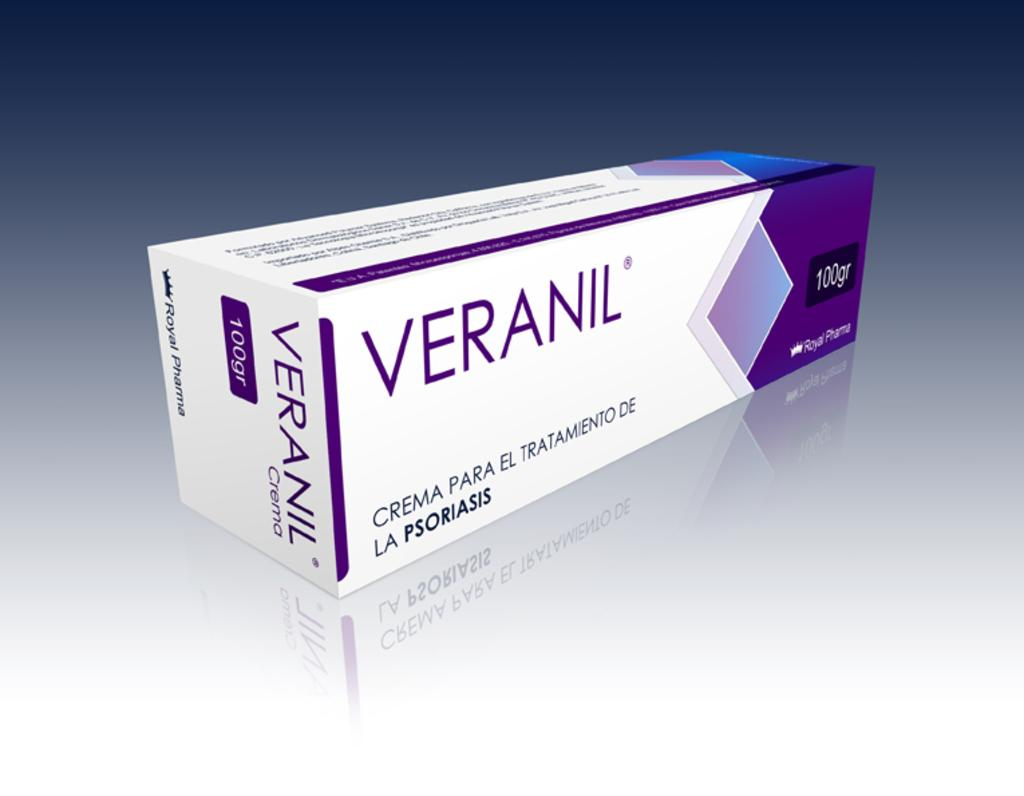<image>
Relay a brief, clear account of the picture shown. The name on the purple, blue and white box called varanil. 